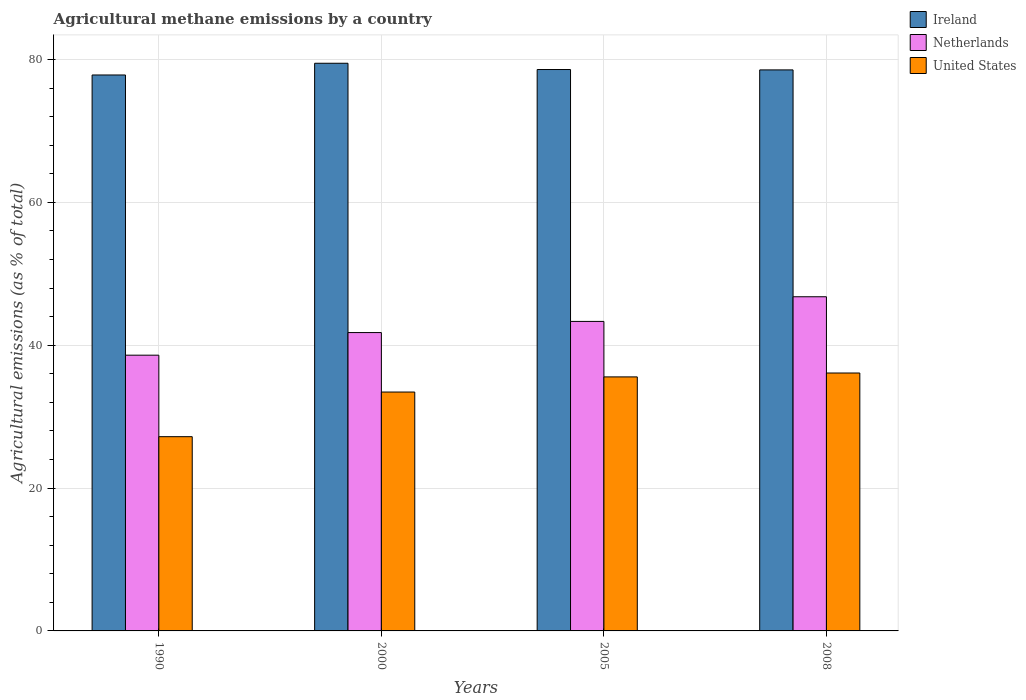How many different coloured bars are there?
Your answer should be compact. 3. How many bars are there on the 2nd tick from the left?
Ensure brevity in your answer.  3. How many bars are there on the 1st tick from the right?
Your answer should be compact. 3. What is the label of the 3rd group of bars from the left?
Ensure brevity in your answer.  2005. In how many cases, is the number of bars for a given year not equal to the number of legend labels?
Offer a terse response. 0. What is the amount of agricultural methane emitted in Netherlands in 2000?
Offer a terse response. 41.77. Across all years, what is the maximum amount of agricultural methane emitted in Ireland?
Give a very brief answer. 79.48. Across all years, what is the minimum amount of agricultural methane emitted in Ireland?
Give a very brief answer. 77.83. In which year was the amount of agricultural methane emitted in United States maximum?
Your answer should be very brief. 2008. In which year was the amount of agricultural methane emitted in Netherlands minimum?
Your answer should be very brief. 1990. What is the total amount of agricultural methane emitted in Ireland in the graph?
Offer a terse response. 314.46. What is the difference between the amount of agricultural methane emitted in Ireland in 1990 and that in 2008?
Offer a very short reply. -0.71. What is the difference between the amount of agricultural methane emitted in Netherlands in 2000 and the amount of agricultural methane emitted in Ireland in 2008?
Provide a succinct answer. -36.77. What is the average amount of agricultural methane emitted in United States per year?
Ensure brevity in your answer.  33.08. In the year 1990, what is the difference between the amount of agricultural methane emitted in Netherlands and amount of agricultural methane emitted in Ireland?
Make the answer very short. -39.23. In how many years, is the amount of agricultural methane emitted in Ireland greater than 36 %?
Keep it short and to the point. 4. What is the ratio of the amount of agricultural methane emitted in Netherlands in 1990 to that in 2005?
Your response must be concise. 0.89. What is the difference between the highest and the second highest amount of agricultural methane emitted in Ireland?
Give a very brief answer. 0.88. What is the difference between the highest and the lowest amount of agricultural methane emitted in United States?
Offer a terse response. 8.92. Is the sum of the amount of agricultural methane emitted in Netherlands in 1990 and 2005 greater than the maximum amount of agricultural methane emitted in Ireland across all years?
Offer a very short reply. Yes. What does the 3rd bar from the left in 2005 represents?
Keep it short and to the point. United States. What does the 2nd bar from the right in 1990 represents?
Make the answer very short. Netherlands. Does the graph contain grids?
Give a very brief answer. Yes. What is the title of the graph?
Your response must be concise. Agricultural methane emissions by a country. Does "Chile" appear as one of the legend labels in the graph?
Provide a succinct answer. No. What is the label or title of the X-axis?
Keep it short and to the point. Years. What is the label or title of the Y-axis?
Make the answer very short. Agricultural emissions (as % of total). What is the Agricultural emissions (as % of total) in Ireland in 1990?
Ensure brevity in your answer.  77.83. What is the Agricultural emissions (as % of total) in Netherlands in 1990?
Provide a short and direct response. 38.61. What is the Agricultural emissions (as % of total) of United States in 1990?
Your answer should be very brief. 27.19. What is the Agricultural emissions (as % of total) in Ireland in 2000?
Your answer should be compact. 79.48. What is the Agricultural emissions (as % of total) in Netherlands in 2000?
Make the answer very short. 41.77. What is the Agricultural emissions (as % of total) in United States in 2000?
Keep it short and to the point. 33.45. What is the Agricultural emissions (as % of total) in Ireland in 2005?
Your answer should be very brief. 78.6. What is the Agricultural emissions (as % of total) in Netherlands in 2005?
Provide a succinct answer. 43.33. What is the Agricultural emissions (as % of total) in United States in 2005?
Provide a short and direct response. 35.56. What is the Agricultural emissions (as % of total) of Ireland in 2008?
Offer a terse response. 78.55. What is the Agricultural emissions (as % of total) of Netherlands in 2008?
Make the answer very short. 46.79. What is the Agricultural emissions (as % of total) in United States in 2008?
Keep it short and to the point. 36.11. Across all years, what is the maximum Agricultural emissions (as % of total) of Ireland?
Offer a very short reply. 79.48. Across all years, what is the maximum Agricultural emissions (as % of total) of Netherlands?
Provide a short and direct response. 46.79. Across all years, what is the maximum Agricultural emissions (as % of total) of United States?
Give a very brief answer. 36.11. Across all years, what is the minimum Agricultural emissions (as % of total) of Ireland?
Provide a succinct answer. 77.83. Across all years, what is the minimum Agricultural emissions (as % of total) in Netherlands?
Your response must be concise. 38.61. Across all years, what is the minimum Agricultural emissions (as % of total) in United States?
Provide a succinct answer. 27.19. What is the total Agricultural emissions (as % of total) in Ireland in the graph?
Your answer should be very brief. 314.46. What is the total Agricultural emissions (as % of total) of Netherlands in the graph?
Your answer should be compact. 170.49. What is the total Agricultural emissions (as % of total) of United States in the graph?
Keep it short and to the point. 132.31. What is the difference between the Agricultural emissions (as % of total) in Ireland in 1990 and that in 2000?
Provide a succinct answer. -1.64. What is the difference between the Agricultural emissions (as % of total) in Netherlands in 1990 and that in 2000?
Give a very brief answer. -3.17. What is the difference between the Agricultural emissions (as % of total) of United States in 1990 and that in 2000?
Provide a succinct answer. -6.25. What is the difference between the Agricultural emissions (as % of total) of Ireland in 1990 and that in 2005?
Provide a short and direct response. -0.76. What is the difference between the Agricultural emissions (as % of total) of Netherlands in 1990 and that in 2005?
Your response must be concise. -4.73. What is the difference between the Agricultural emissions (as % of total) in United States in 1990 and that in 2005?
Your response must be concise. -8.37. What is the difference between the Agricultural emissions (as % of total) of Ireland in 1990 and that in 2008?
Offer a terse response. -0.71. What is the difference between the Agricultural emissions (as % of total) in Netherlands in 1990 and that in 2008?
Offer a terse response. -8.18. What is the difference between the Agricultural emissions (as % of total) in United States in 1990 and that in 2008?
Offer a terse response. -8.92. What is the difference between the Agricultural emissions (as % of total) of Ireland in 2000 and that in 2005?
Make the answer very short. 0.88. What is the difference between the Agricultural emissions (as % of total) of Netherlands in 2000 and that in 2005?
Make the answer very short. -1.56. What is the difference between the Agricultural emissions (as % of total) in United States in 2000 and that in 2005?
Give a very brief answer. -2.12. What is the difference between the Agricultural emissions (as % of total) in Ireland in 2000 and that in 2008?
Give a very brief answer. 0.93. What is the difference between the Agricultural emissions (as % of total) in Netherlands in 2000 and that in 2008?
Make the answer very short. -5.01. What is the difference between the Agricultural emissions (as % of total) of United States in 2000 and that in 2008?
Your answer should be very brief. -2.66. What is the difference between the Agricultural emissions (as % of total) in Ireland in 2005 and that in 2008?
Provide a short and direct response. 0.05. What is the difference between the Agricultural emissions (as % of total) of Netherlands in 2005 and that in 2008?
Your answer should be compact. -3.45. What is the difference between the Agricultural emissions (as % of total) in United States in 2005 and that in 2008?
Ensure brevity in your answer.  -0.54. What is the difference between the Agricultural emissions (as % of total) in Ireland in 1990 and the Agricultural emissions (as % of total) in Netherlands in 2000?
Provide a short and direct response. 36.06. What is the difference between the Agricultural emissions (as % of total) in Ireland in 1990 and the Agricultural emissions (as % of total) in United States in 2000?
Give a very brief answer. 44.39. What is the difference between the Agricultural emissions (as % of total) in Netherlands in 1990 and the Agricultural emissions (as % of total) in United States in 2000?
Offer a very short reply. 5.16. What is the difference between the Agricultural emissions (as % of total) of Ireland in 1990 and the Agricultural emissions (as % of total) of Netherlands in 2005?
Make the answer very short. 34.5. What is the difference between the Agricultural emissions (as % of total) of Ireland in 1990 and the Agricultural emissions (as % of total) of United States in 2005?
Your response must be concise. 42.27. What is the difference between the Agricultural emissions (as % of total) in Netherlands in 1990 and the Agricultural emissions (as % of total) in United States in 2005?
Provide a succinct answer. 3.04. What is the difference between the Agricultural emissions (as % of total) of Ireland in 1990 and the Agricultural emissions (as % of total) of Netherlands in 2008?
Provide a short and direct response. 31.05. What is the difference between the Agricultural emissions (as % of total) in Ireland in 1990 and the Agricultural emissions (as % of total) in United States in 2008?
Ensure brevity in your answer.  41.73. What is the difference between the Agricultural emissions (as % of total) in Netherlands in 1990 and the Agricultural emissions (as % of total) in United States in 2008?
Your answer should be very brief. 2.5. What is the difference between the Agricultural emissions (as % of total) of Ireland in 2000 and the Agricultural emissions (as % of total) of Netherlands in 2005?
Your answer should be compact. 36.14. What is the difference between the Agricultural emissions (as % of total) in Ireland in 2000 and the Agricultural emissions (as % of total) in United States in 2005?
Make the answer very short. 43.91. What is the difference between the Agricultural emissions (as % of total) of Netherlands in 2000 and the Agricultural emissions (as % of total) of United States in 2005?
Make the answer very short. 6.21. What is the difference between the Agricultural emissions (as % of total) of Ireland in 2000 and the Agricultural emissions (as % of total) of Netherlands in 2008?
Offer a terse response. 32.69. What is the difference between the Agricultural emissions (as % of total) of Ireland in 2000 and the Agricultural emissions (as % of total) of United States in 2008?
Provide a succinct answer. 43.37. What is the difference between the Agricultural emissions (as % of total) in Netherlands in 2000 and the Agricultural emissions (as % of total) in United States in 2008?
Your response must be concise. 5.66. What is the difference between the Agricultural emissions (as % of total) of Ireland in 2005 and the Agricultural emissions (as % of total) of Netherlands in 2008?
Offer a terse response. 31.81. What is the difference between the Agricultural emissions (as % of total) of Ireland in 2005 and the Agricultural emissions (as % of total) of United States in 2008?
Offer a terse response. 42.49. What is the difference between the Agricultural emissions (as % of total) of Netherlands in 2005 and the Agricultural emissions (as % of total) of United States in 2008?
Your answer should be very brief. 7.22. What is the average Agricultural emissions (as % of total) of Ireland per year?
Offer a very short reply. 78.61. What is the average Agricultural emissions (as % of total) of Netherlands per year?
Provide a short and direct response. 42.62. What is the average Agricultural emissions (as % of total) in United States per year?
Your response must be concise. 33.08. In the year 1990, what is the difference between the Agricultural emissions (as % of total) of Ireland and Agricultural emissions (as % of total) of Netherlands?
Offer a terse response. 39.23. In the year 1990, what is the difference between the Agricultural emissions (as % of total) in Ireland and Agricultural emissions (as % of total) in United States?
Offer a terse response. 50.64. In the year 1990, what is the difference between the Agricultural emissions (as % of total) of Netherlands and Agricultural emissions (as % of total) of United States?
Ensure brevity in your answer.  11.41. In the year 2000, what is the difference between the Agricultural emissions (as % of total) in Ireland and Agricultural emissions (as % of total) in Netherlands?
Offer a terse response. 37.7. In the year 2000, what is the difference between the Agricultural emissions (as % of total) of Ireland and Agricultural emissions (as % of total) of United States?
Offer a terse response. 46.03. In the year 2000, what is the difference between the Agricultural emissions (as % of total) of Netherlands and Agricultural emissions (as % of total) of United States?
Your response must be concise. 8.33. In the year 2005, what is the difference between the Agricultural emissions (as % of total) in Ireland and Agricultural emissions (as % of total) in Netherlands?
Your response must be concise. 35.27. In the year 2005, what is the difference between the Agricultural emissions (as % of total) of Ireland and Agricultural emissions (as % of total) of United States?
Your answer should be compact. 43.03. In the year 2005, what is the difference between the Agricultural emissions (as % of total) of Netherlands and Agricultural emissions (as % of total) of United States?
Provide a short and direct response. 7.77. In the year 2008, what is the difference between the Agricultural emissions (as % of total) of Ireland and Agricultural emissions (as % of total) of Netherlands?
Keep it short and to the point. 31.76. In the year 2008, what is the difference between the Agricultural emissions (as % of total) in Ireland and Agricultural emissions (as % of total) in United States?
Provide a short and direct response. 42.44. In the year 2008, what is the difference between the Agricultural emissions (as % of total) of Netherlands and Agricultural emissions (as % of total) of United States?
Your answer should be very brief. 10.68. What is the ratio of the Agricultural emissions (as % of total) of Ireland in 1990 to that in 2000?
Provide a short and direct response. 0.98. What is the ratio of the Agricultural emissions (as % of total) of Netherlands in 1990 to that in 2000?
Offer a terse response. 0.92. What is the ratio of the Agricultural emissions (as % of total) of United States in 1990 to that in 2000?
Offer a terse response. 0.81. What is the ratio of the Agricultural emissions (as % of total) in Ireland in 1990 to that in 2005?
Provide a succinct answer. 0.99. What is the ratio of the Agricultural emissions (as % of total) in Netherlands in 1990 to that in 2005?
Your answer should be very brief. 0.89. What is the ratio of the Agricultural emissions (as % of total) in United States in 1990 to that in 2005?
Make the answer very short. 0.76. What is the ratio of the Agricultural emissions (as % of total) in Ireland in 1990 to that in 2008?
Your answer should be compact. 0.99. What is the ratio of the Agricultural emissions (as % of total) in Netherlands in 1990 to that in 2008?
Provide a short and direct response. 0.83. What is the ratio of the Agricultural emissions (as % of total) of United States in 1990 to that in 2008?
Give a very brief answer. 0.75. What is the ratio of the Agricultural emissions (as % of total) in Ireland in 2000 to that in 2005?
Ensure brevity in your answer.  1.01. What is the ratio of the Agricultural emissions (as % of total) of United States in 2000 to that in 2005?
Give a very brief answer. 0.94. What is the ratio of the Agricultural emissions (as % of total) of Ireland in 2000 to that in 2008?
Provide a short and direct response. 1.01. What is the ratio of the Agricultural emissions (as % of total) of Netherlands in 2000 to that in 2008?
Offer a terse response. 0.89. What is the ratio of the Agricultural emissions (as % of total) in United States in 2000 to that in 2008?
Offer a very short reply. 0.93. What is the ratio of the Agricultural emissions (as % of total) of Ireland in 2005 to that in 2008?
Ensure brevity in your answer.  1. What is the ratio of the Agricultural emissions (as % of total) in Netherlands in 2005 to that in 2008?
Provide a succinct answer. 0.93. What is the ratio of the Agricultural emissions (as % of total) in United States in 2005 to that in 2008?
Provide a succinct answer. 0.98. What is the difference between the highest and the second highest Agricultural emissions (as % of total) of Ireland?
Keep it short and to the point. 0.88. What is the difference between the highest and the second highest Agricultural emissions (as % of total) of Netherlands?
Your response must be concise. 3.45. What is the difference between the highest and the second highest Agricultural emissions (as % of total) in United States?
Give a very brief answer. 0.54. What is the difference between the highest and the lowest Agricultural emissions (as % of total) in Ireland?
Give a very brief answer. 1.64. What is the difference between the highest and the lowest Agricultural emissions (as % of total) in Netherlands?
Keep it short and to the point. 8.18. What is the difference between the highest and the lowest Agricultural emissions (as % of total) in United States?
Give a very brief answer. 8.92. 